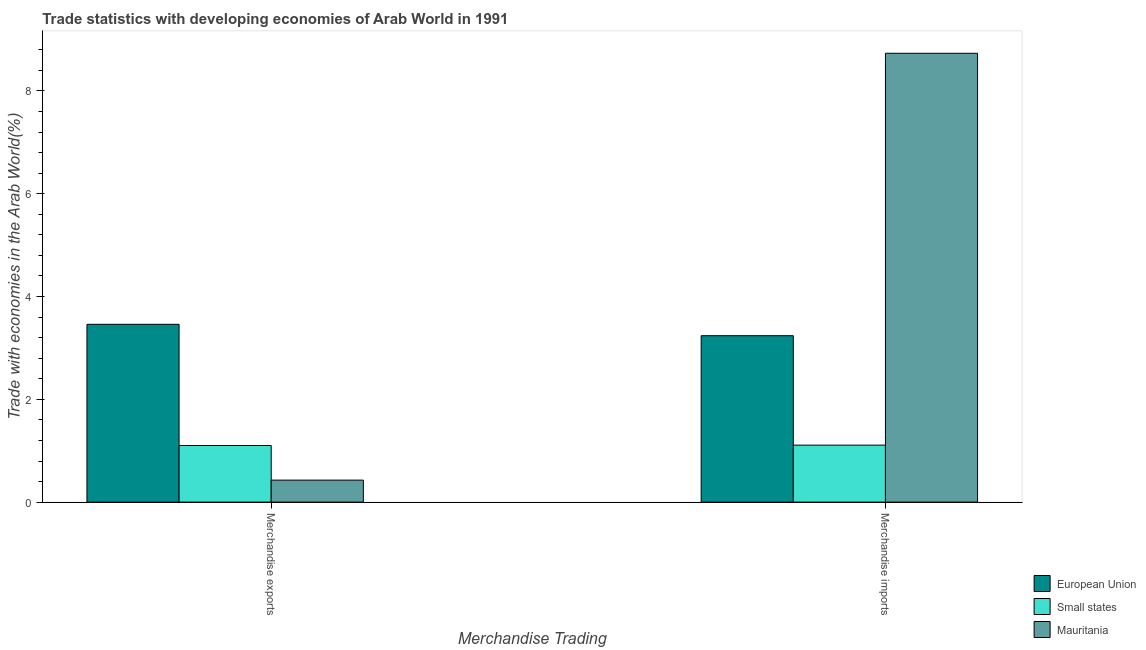How many groups of bars are there?
Your response must be concise. 2. Are the number of bars per tick equal to the number of legend labels?
Make the answer very short. Yes. How many bars are there on the 2nd tick from the right?
Offer a terse response. 3. What is the label of the 2nd group of bars from the left?
Provide a short and direct response. Merchandise imports. What is the merchandise imports in Small states?
Provide a short and direct response. 1.11. Across all countries, what is the maximum merchandise exports?
Ensure brevity in your answer.  3.46. Across all countries, what is the minimum merchandise imports?
Your response must be concise. 1.11. In which country was the merchandise imports maximum?
Provide a short and direct response. Mauritania. In which country was the merchandise imports minimum?
Your answer should be very brief. Small states. What is the total merchandise imports in the graph?
Keep it short and to the point. 13.08. What is the difference between the merchandise imports in Mauritania and that in European Union?
Your answer should be very brief. 5.5. What is the difference between the merchandise exports in European Union and the merchandise imports in Small states?
Your answer should be very brief. 2.35. What is the average merchandise imports per country?
Provide a succinct answer. 4.36. What is the difference between the merchandise imports and merchandise exports in Mauritania?
Offer a very short reply. 8.31. In how many countries, is the merchandise imports greater than 5.6 %?
Ensure brevity in your answer.  1. What is the ratio of the merchandise exports in European Union to that in Small states?
Ensure brevity in your answer.  3.14. In how many countries, is the merchandise imports greater than the average merchandise imports taken over all countries?
Keep it short and to the point. 1. What is the difference between two consecutive major ticks on the Y-axis?
Give a very brief answer. 2. Are the values on the major ticks of Y-axis written in scientific E-notation?
Offer a very short reply. No. Does the graph contain grids?
Make the answer very short. No. Where does the legend appear in the graph?
Provide a succinct answer. Bottom right. How are the legend labels stacked?
Your response must be concise. Vertical. What is the title of the graph?
Offer a terse response. Trade statistics with developing economies of Arab World in 1991. Does "Swaziland" appear as one of the legend labels in the graph?
Make the answer very short. No. What is the label or title of the X-axis?
Ensure brevity in your answer.  Merchandise Trading. What is the label or title of the Y-axis?
Your answer should be very brief. Trade with economies in the Arab World(%). What is the Trade with economies in the Arab World(%) in European Union in Merchandise exports?
Provide a succinct answer. 3.46. What is the Trade with economies in the Arab World(%) of Small states in Merchandise exports?
Your answer should be very brief. 1.1. What is the Trade with economies in the Arab World(%) of Mauritania in Merchandise exports?
Your answer should be compact. 0.43. What is the Trade with economies in the Arab World(%) of European Union in Merchandise imports?
Provide a short and direct response. 3.24. What is the Trade with economies in the Arab World(%) of Small states in Merchandise imports?
Your answer should be very brief. 1.11. What is the Trade with economies in the Arab World(%) in Mauritania in Merchandise imports?
Provide a short and direct response. 8.73. Across all Merchandise Trading, what is the maximum Trade with economies in the Arab World(%) of European Union?
Your response must be concise. 3.46. Across all Merchandise Trading, what is the maximum Trade with economies in the Arab World(%) of Small states?
Provide a short and direct response. 1.11. Across all Merchandise Trading, what is the maximum Trade with economies in the Arab World(%) in Mauritania?
Provide a succinct answer. 8.73. Across all Merchandise Trading, what is the minimum Trade with economies in the Arab World(%) of European Union?
Provide a succinct answer. 3.24. Across all Merchandise Trading, what is the minimum Trade with economies in the Arab World(%) in Small states?
Keep it short and to the point. 1.1. Across all Merchandise Trading, what is the minimum Trade with economies in the Arab World(%) of Mauritania?
Keep it short and to the point. 0.43. What is the total Trade with economies in the Arab World(%) in European Union in the graph?
Ensure brevity in your answer.  6.7. What is the total Trade with economies in the Arab World(%) in Small states in the graph?
Ensure brevity in your answer.  2.21. What is the total Trade with economies in the Arab World(%) of Mauritania in the graph?
Give a very brief answer. 9.16. What is the difference between the Trade with economies in the Arab World(%) of European Union in Merchandise exports and that in Merchandise imports?
Your answer should be compact. 0.22. What is the difference between the Trade with economies in the Arab World(%) of Small states in Merchandise exports and that in Merchandise imports?
Your answer should be compact. -0.01. What is the difference between the Trade with economies in the Arab World(%) of Mauritania in Merchandise exports and that in Merchandise imports?
Your answer should be very brief. -8.31. What is the difference between the Trade with economies in the Arab World(%) of European Union in Merchandise exports and the Trade with economies in the Arab World(%) of Small states in Merchandise imports?
Your response must be concise. 2.35. What is the difference between the Trade with economies in the Arab World(%) of European Union in Merchandise exports and the Trade with economies in the Arab World(%) of Mauritania in Merchandise imports?
Your response must be concise. -5.27. What is the difference between the Trade with economies in the Arab World(%) of Small states in Merchandise exports and the Trade with economies in the Arab World(%) of Mauritania in Merchandise imports?
Your response must be concise. -7.63. What is the average Trade with economies in the Arab World(%) in European Union per Merchandise Trading?
Your response must be concise. 3.35. What is the average Trade with economies in the Arab World(%) in Small states per Merchandise Trading?
Give a very brief answer. 1.11. What is the average Trade with economies in the Arab World(%) in Mauritania per Merchandise Trading?
Provide a succinct answer. 4.58. What is the difference between the Trade with economies in the Arab World(%) of European Union and Trade with economies in the Arab World(%) of Small states in Merchandise exports?
Ensure brevity in your answer.  2.36. What is the difference between the Trade with economies in the Arab World(%) in European Union and Trade with economies in the Arab World(%) in Mauritania in Merchandise exports?
Provide a short and direct response. 3.03. What is the difference between the Trade with economies in the Arab World(%) in Small states and Trade with economies in the Arab World(%) in Mauritania in Merchandise exports?
Give a very brief answer. 0.67. What is the difference between the Trade with economies in the Arab World(%) of European Union and Trade with economies in the Arab World(%) of Small states in Merchandise imports?
Ensure brevity in your answer.  2.13. What is the difference between the Trade with economies in the Arab World(%) in European Union and Trade with economies in the Arab World(%) in Mauritania in Merchandise imports?
Keep it short and to the point. -5.5. What is the difference between the Trade with economies in the Arab World(%) in Small states and Trade with economies in the Arab World(%) in Mauritania in Merchandise imports?
Provide a short and direct response. -7.62. What is the ratio of the Trade with economies in the Arab World(%) in European Union in Merchandise exports to that in Merchandise imports?
Offer a very short reply. 1.07. What is the ratio of the Trade with economies in the Arab World(%) in Small states in Merchandise exports to that in Merchandise imports?
Offer a terse response. 0.99. What is the ratio of the Trade with economies in the Arab World(%) of Mauritania in Merchandise exports to that in Merchandise imports?
Your response must be concise. 0.05. What is the difference between the highest and the second highest Trade with economies in the Arab World(%) in European Union?
Your response must be concise. 0.22. What is the difference between the highest and the second highest Trade with economies in the Arab World(%) in Small states?
Your answer should be compact. 0.01. What is the difference between the highest and the second highest Trade with economies in the Arab World(%) of Mauritania?
Your answer should be compact. 8.31. What is the difference between the highest and the lowest Trade with economies in the Arab World(%) in European Union?
Keep it short and to the point. 0.22. What is the difference between the highest and the lowest Trade with economies in the Arab World(%) in Small states?
Keep it short and to the point. 0.01. What is the difference between the highest and the lowest Trade with economies in the Arab World(%) of Mauritania?
Offer a terse response. 8.31. 